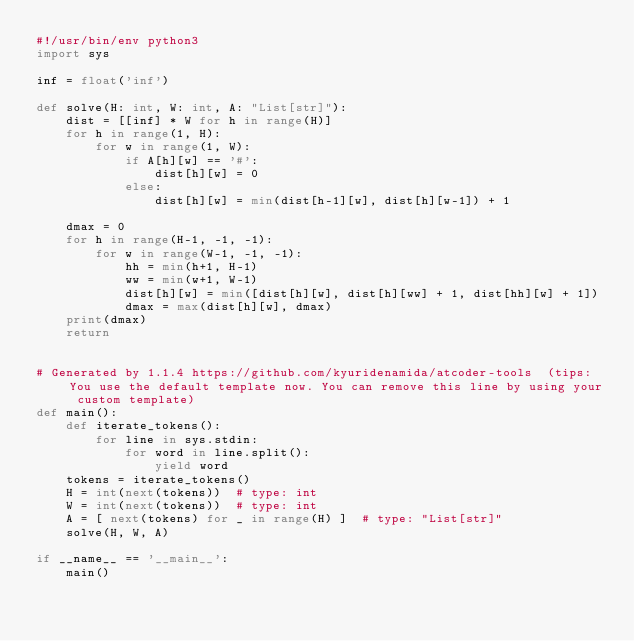Convert code to text. <code><loc_0><loc_0><loc_500><loc_500><_Python_>#!/usr/bin/env python3
import sys

inf = float('inf')

def solve(H: int, W: int, A: "List[str]"):
    dist = [[inf] * W for h in range(H)]
    for h in range(1, H):
        for w in range(1, W):
            if A[h][w] == '#':
                dist[h][w] = 0
            else:
                dist[h][w] = min(dist[h-1][w], dist[h][w-1]) + 1
    
    dmax = 0
    for h in range(H-1, -1, -1):
        for w in range(W-1, -1, -1):
            hh = min(h+1, H-1)
            ww = min(w+1, W-1)
            dist[h][w] = min([dist[h][w], dist[h][ww] + 1, dist[hh][w] + 1])
            dmax = max(dist[h][w], dmax)
    print(dmax) 
    return


# Generated by 1.1.4 https://github.com/kyuridenamida/atcoder-tools  (tips: You use the default template now. You can remove this line by using your custom template)
def main():
    def iterate_tokens():
        for line in sys.stdin:
            for word in line.split():
                yield word
    tokens = iterate_tokens()
    H = int(next(tokens))  # type: int
    W = int(next(tokens))  # type: int
    A = [ next(tokens) for _ in range(H) ]  # type: "List[str]"
    solve(H, W, A)

if __name__ == '__main__':
    main()
</code> 